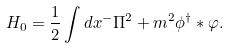Convert formula to latex. <formula><loc_0><loc_0><loc_500><loc_500>H _ { 0 } = \frac { 1 } { 2 } \int d x ^ { - } \Pi ^ { 2 } + m ^ { 2 } \phi ^ { \dag } \ast \varphi .</formula> 